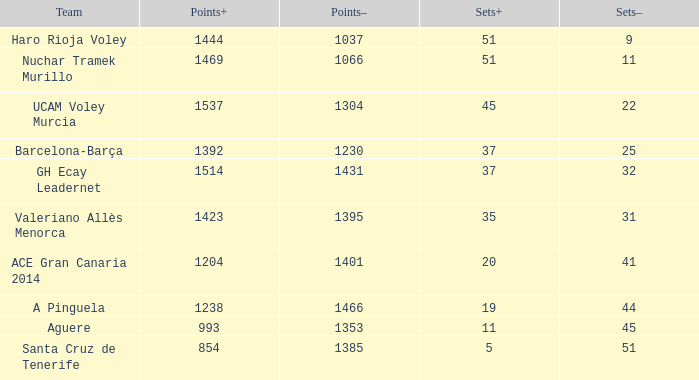What is the highest Points+ number when the Points- number is larger than 1385, a Sets+ number smaller than 37 and a Sets- number larger than 41? 1238.0. 